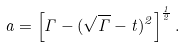<formula> <loc_0><loc_0><loc_500><loc_500>a = \left [ \Gamma - ( \sqrt { \Gamma } - t ) ^ { 2 } \right ] ^ { \frac { 1 } { 2 } } .</formula> 